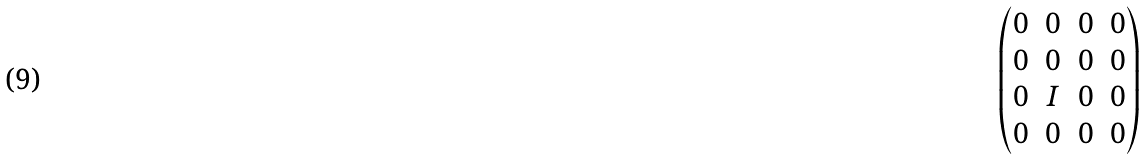Convert formula to latex. <formula><loc_0><loc_0><loc_500><loc_500>\begin{pmatrix} 0 & 0 & 0 & 0 \\ 0 & 0 & 0 & 0 \\ 0 & I & 0 & 0 \\ 0 & 0 & 0 & 0 \\ \end{pmatrix}</formula> 